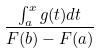Convert formula to latex. <formula><loc_0><loc_0><loc_500><loc_500>\frac { \int _ { a } ^ { x } g ( t ) d t } { F ( b ) - F ( a ) }</formula> 